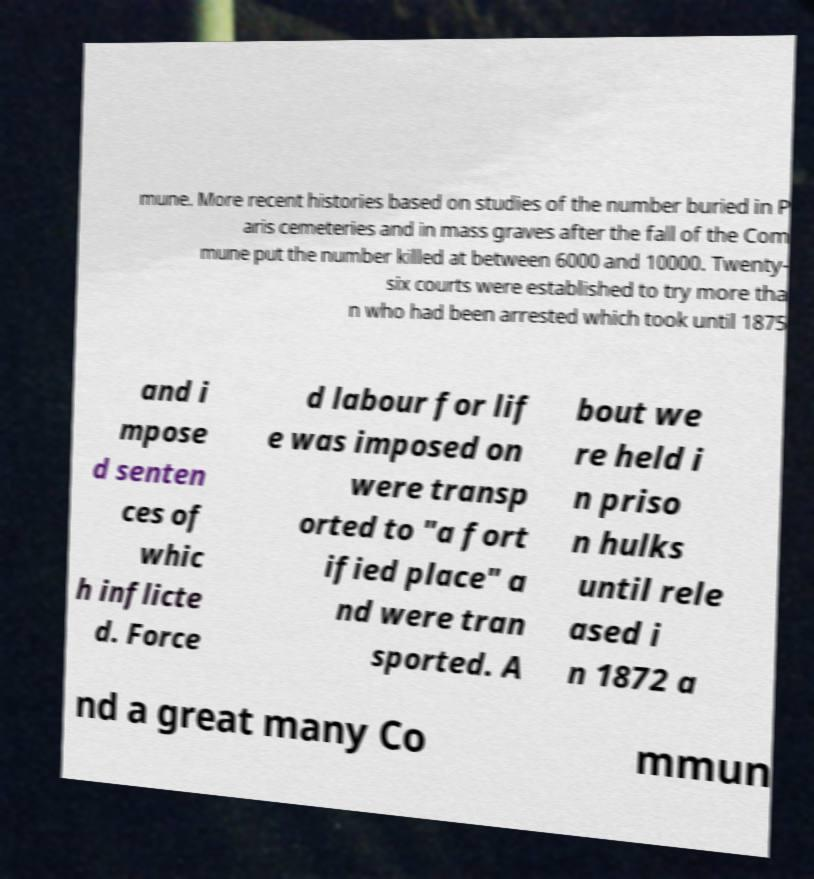Could you extract and type out the text from this image? mune. More recent histories based on studies of the number buried in P aris cemeteries and in mass graves after the fall of the Com mune put the number killed at between 6000 and 10000. Twenty- six courts were established to try more tha n who had been arrested which took until 1875 and i mpose d senten ces of whic h inflicte d. Force d labour for lif e was imposed on were transp orted to "a fort ified place" a nd were tran sported. A bout we re held i n priso n hulks until rele ased i n 1872 a nd a great many Co mmun 